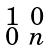<formula> <loc_0><loc_0><loc_500><loc_500>\begin{smallmatrix} 1 & 0 \\ 0 & n \end{smallmatrix}</formula> 